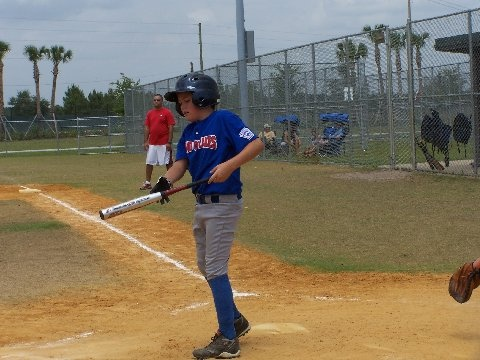Describe the objects in this image and their specific colors. I can see people in darkgray, navy, gray, black, and maroon tones, people in darkgray, maroon, brown, and gray tones, baseball bat in darkgray, black, gray, and lightgray tones, people in darkgray, maroon, black, and brown tones, and baseball glove in darkgray, maroon, black, and gray tones in this image. 